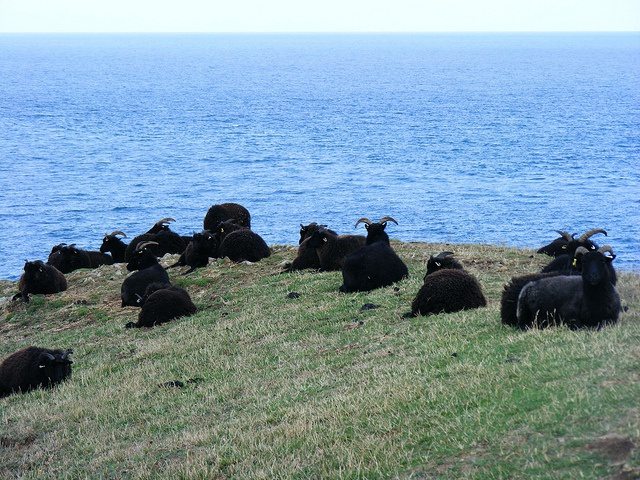Describe the objects in this image and their specific colors. I can see sheep in white, black, gray, lightblue, and darkgray tones, sheep in white, black, and gray tones, sheep in white, black, and gray tones, sheep in white, black, gray, and navy tones, and sheep in white, black, gray, and darkblue tones in this image. 